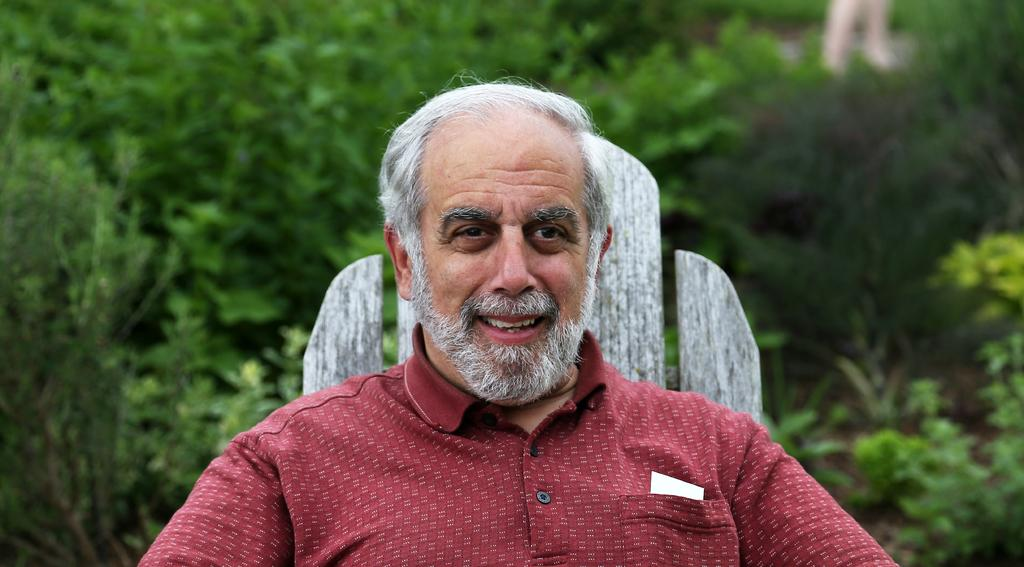Who is present in the image? There is a man in the image. What is the man wearing? The man is wearing a shirt. What can be seen behind the man? There is a wooden object behind the man. What type of natural elements can be seen in the background of the image? There are plants visible in the background of the image. What type of disease is the man suffering from in the image? There is no indication of any disease in the image; the man appears to be healthy and is simply standing in front of a wooden object. 